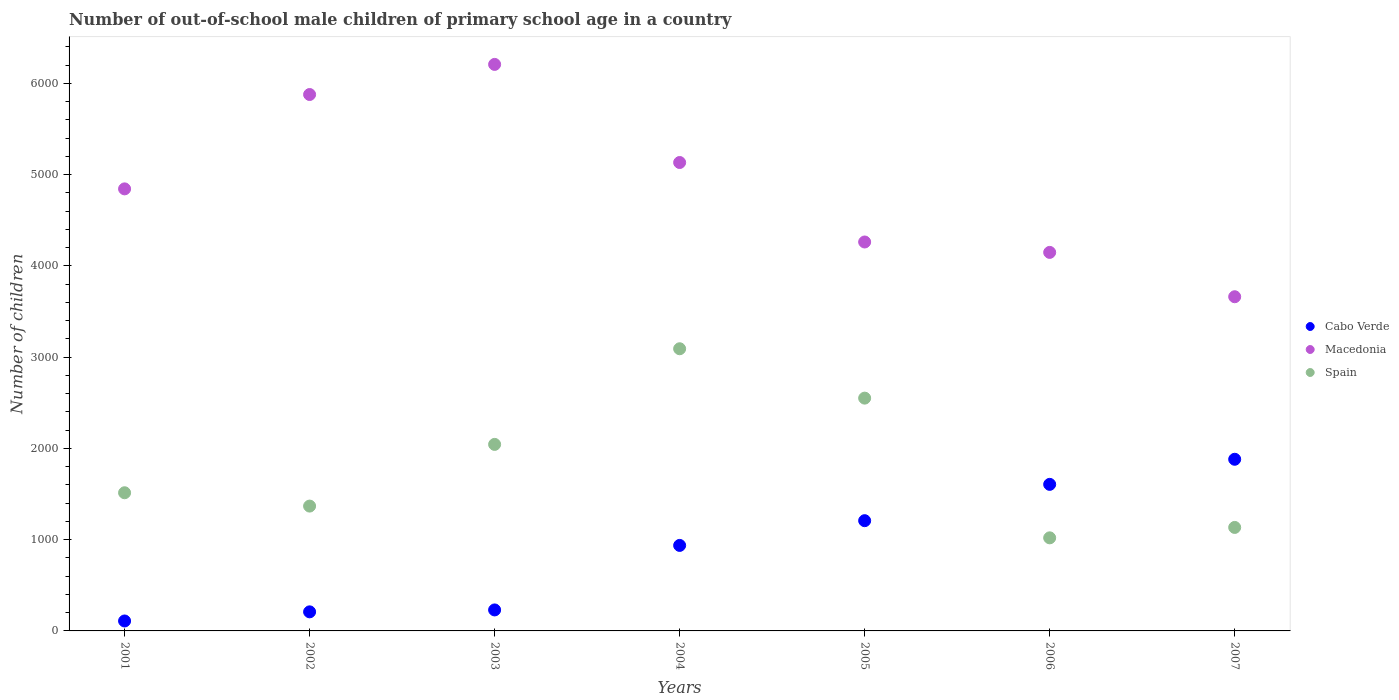How many different coloured dotlines are there?
Ensure brevity in your answer.  3. What is the number of out-of-school male children in Cabo Verde in 2003?
Ensure brevity in your answer.  230. Across all years, what is the maximum number of out-of-school male children in Spain?
Your response must be concise. 3092. Across all years, what is the minimum number of out-of-school male children in Cabo Verde?
Make the answer very short. 109. In which year was the number of out-of-school male children in Spain minimum?
Provide a succinct answer. 2006. What is the total number of out-of-school male children in Macedonia in the graph?
Give a very brief answer. 3.41e+04. What is the difference between the number of out-of-school male children in Spain in 2003 and that in 2005?
Make the answer very short. -507. What is the difference between the number of out-of-school male children in Spain in 2003 and the number of out-of-school male children in Cabo Verde in 2001?
Offer a very short reply. 1935. What is the average number of out-of-school male children in Spain per year?
Make the answer very short. 1817.57. In the year 2002, what is the difference between the number of out-of-school male children in Macedonia and number of out-of-school male children in Cabo Verde?
Your answer should be compact. 5669. In how many years, is the number of out-of-school male children in Cabo Verde greater than 1000?
Ensure brevity in your answer.  3. What is the ratio of the number of out-of-school male children in Macedonia in 2002 to that in 2006?
Your answer should be very brief. 1.42. Is the number of out-of-school male children in Macedonia in 2001 less than that in 2002?
Your answer should be compact. Yes. Is the difference between the number of out-of-school male children in Macedonia in 2003 and 2004 greater than the difference between the number of out-of-school male children in Cabo Verde in 2003 and 2004?
Ensure brevity in your answer.  Yes. What is the difference between the highest and the second highest number of out-of-school male children in Cabo Verde?
Your response must be concise. 275. What is the difference between the highest and the lowest number of out-of-school male children in Cabo Verde?
Offer a very short reply. 1772. In how many years, is the number of out-of-school male children in Spain greater than the average number of out-of-school male children in Spain taken over all years?
Your response must be concise. 3. Is the number of out-of-school male children in Macedonia strictly greater than the number of out-of-school male children in Cabo Verde over the years?
Provide a succinct answer. Yes. Is the number of out-of-school male children in Macedonia strictly less than the number of out-of-school male children in Spain over the years?
Give a very brief answer. No. How many years are there in the graph?
Give a very brief answer. 7. What is the difference between two consecutive major ticks on the Y-axis?
Keep it short and to the point. 1000. Are the values on the major ticks of Y-axis written in scientific E-notation?
Ensure brevity in your answer.  No. Does the graph contain grids?
Offer a terse response. No. How many legend labels are there?
Keep it short and to the point. 3. What is the title of the graph?
Your answer should be very brief. Number of out-of-school male children of primary school age in a country. Does "Bulgaria" appear as one of the legend labels in the graph?
Provide a short and direct response. No. What is the label or title of the Y-axis?
Ensure brevity in your answer.  Number of children. What is the Number of children in Cabo Verde in 2001?
Provide a short and direct response. 109. What is the Number of children of Macedonia in 2001?
Make the answer very short. 4844. What is the Number of children in Spain in 2001?
Your response must be concise. 1514. What is the Number of children in Cabo Verde in 2002?
Your response must be concise. 209. What is the Number of children of Macedonia in 2002?
Offer a very short reply. 5878. What is the Number of children in Spain in 2002?
Offer a terse response. 1368. What is the Number of children in Cabo Verde in 2003?
Ensure brevity in your answer.  230. What is the Number of children in Macedonia in 2003?
Provide a succinct answer. 6208. What is the Number of children of Spain in 2003?
Make the answer very short. 2044. What is the Number of children in Cabo Verde in 2004?
Give a very brief answer. 937. What is the Number of children of Macedonia in 2004?
Your response must be concise. 5133. What is the Number of children of Spain in 2004?
Give a very brief answer. 3092. What is the Number of children in Cabo Verde in 2005?
Your answer should be compact. 1208. What is the Number of children in Macedonia in 2005?
Ensure brevity in your answer.  4262. What is the Number of children in Spain in 2005?
Your response must be concise. 2551. What is the Number of children in Cabo Verde in 2006?
Keep it short and to the point. 1606. What is the Number of children in Macedonia in 2006?
Give a very brief answer. 4148. What is the Number of children of Spain in 2006?
Give a very brief answer. 1020. What is the Number of children of Cabo Verde in 2007?
Provide a short and direct response. 1881. What is the Number of children of Macedonia in 2007?
Your answer should be compact. 3662. What is the Number of children in Spain in 2007?
Provide a short and direct response. 1134. Across all years, what is the maximum Number of children of Cabo Verde?
Give a very brief answer. 1881. Across all years, what is the maximum Number of children of Macedonia?
Provide a short and direct response. 6208. Across all years, what is the maximum Number of children in Spain?
Ensure brevity in your answer.  3092. Across all years, what is the minimum Number of children of Cabo Verde?
Your answer should be compact. 109. Across all years, what is the minimum Number of children in Macedonia?
Give a very brief answer. 3662. Across all years, what is the minimum Number of children of Spain?
Offer a very short reply. 1020. What is the total Number of children in Cabo Verde in the graph?
Make the answer very short. 6180. What is the total Number of children of Macedonia in the graph?
Your answer should be very brief. 3.41e+04. What is the total Number of children in Spain in the graph?
Your answer should be very brief. 1.27e+04. What is the difference between the Number of children of Cabo Verde in 2001 and that in 2002?
Make the answer very short. -100. What is the difference between the Number of children of Macedonia in 2001 and that in 2002?
Keep it short and to the point. -1034. What is the difference between the Number of children in Spain in 2001 and that in 2002?
Offer a terse response. 146. What is the difference between the Number of children of Cabo Verde in 2001 and that in 2003?
Your answer should be compact. -121. What is the difference between the Number of children of Macedonia in 2001 and that in 2003?
Offer a terse response. -1364. What is the difference between the Number of children of Spain in 2001 and that in 2003?
Your answer should be very brief. -530. What is the difference between the Number of children of Cabo Verde in 2001 and that in 2004?
Your answer should be compact. -828. What is the difference between the Number of children of Macedonia in 2001 and that in 2004?
Your answer should be compact. -289. What is the difference between the Number of children of Spain in 2001 and that in 2004?
Your response must be concise. -1578. What is the difference between the Number of children of Cabo Verde in 2001 and that in 2005?
Keep it short and to the point. -1099. What is the difference between the Number of children in Macedonia in 2001 and that in 2005?
Your response must be concise. 582. What is the difference between the Number of children in Spain in 2001 and that in 2005?
Keep it short and to the point. -1037. What is the difference between the Number of children of Cabo Verde in 2001 and that in 2006?
Your answer should be very brief. -1497. What is the difference between the Number of children in Macedonia in 2001 and that in 2006?
Your response must be concise. 696. What is the difference between the Number of children of Spain in 2001 and that in 2006?
Provide a succinct answer. 494. What is the difference between the Number of children in Cabo Verde in 2001 and that in 2007?
Offer a very short reply. -1772. What is the difference between the Number of children of Macedonia in 2001 and that in 2007?
Make the answer very short. 1182. What is the difference between the Number of children of Spain in 2001 and that in 2007?
Ensure brevity in your answer.  380. What is the difference between the Number of children of Cabo Verde in 2002 and that in 2003?
Your answer should be very brief. -21. What is the difference between the Number of children in Macedonia in 2002 and that in 2003?
Make the answer very short. -330. What is the difference between the Number of children in Spain in 2002 and that in 2003?
Your answer should be very brief. -676. What is the difference between the Number of children of Cabo Verde in 2002 and that in 2004?
Give a very brief answer. -728. What is the difference between the Number of children in Macedonia in 2002 and that in 2004?
Your answer should be very brief. 745. What is the difference between the Number of children in Spain in 2002 and that in 2004?
Offer a very short reply. -1724. What is the difference between the Number of children of Cabo Verde in 2002 and that in 2005?
Provide a succinct answer. -999. What is the difference between the Number of children in Macedonia in 2002 and that in 2005?
Keep it short and to the point. 1616. What is the difference between the Number of children of Spain in 2002 and that in 2005?
Make the answer very short. -1183. What is the difference between the Number of children of Cabo Verde in 2002 and that in 2006?
Your answer should be compact. -1397. What is the difference between the Number of children of Macedonia in 2002 and that in 2006?
Your response must be concise. 1730. What is the difference between the Number of children in Spain in 2002 and that in 2006?
Offer a terse response. 348. What is the difference between the Number of children of Cabo Verde in 2002 and that in 2007?
Your answer should be very brief. -1672. What is the difference between the Number of children of Macedonia in 2002 and that in 2007?
Make the answer very short. 2216. What is the difference between the Number of children in Spain in 2002 and that in 2007?
Your response must be concise. 234. What is the difference between the Number of children of Cabo Verde in 2003 and that in 2004?
Provide a short and direct response. -707. What is the difference between the Number of children in Macedonia in 2003 and that in 2004?
Provide a succinct answer. 1075. What is the difference between the Number of children in Spain in 2003 and that in 2004?
Offer a terse response. -1048. What is the difference between the Number of children in Cabo Verde in 2003 and that in 2005?
Ensure brevity in your answer.  -978. What is the difference between the Number of children in Macedonia in 2003 and that in 2005?
Ensure brevity in your answer.  1946. What is the difference between the Number of children in Spain in 2003 and that in 2005?
Provide a short and direct response. -507. What is the difference between the Number of children of Cabo Verde in 2003 and that in 2006?
Keep it short and to the point. -1376. What is the difference between the Number of children in Macedonia in 2003 and that in 2006?
Give a very brief answer. 2060. What is the difference between the Number of children in Spain in 2003 and that in 2006?
Offer a very short reply. 1024. What is the difference between the Number of children in Cabo Verde in 2003 and that in 2007?
Your answer should be compact. -1651. What is the difference between the Number of children of Macedonia in 2003 and that in 2007?
Your answer should be compact. 2546. What is the difference between the Number of children in Spain in 2003 and that in 2007?
Ensure brevity in your answer.  910. What is the difference between the Number of children in Cabo Verde in 2004 and that in 2005?
Give a very brief answer. -271. What is the difference between the Number of children of Macedonia in 2004 and that in 2005?
Your response must be concise. 871. What is the difference between the Number of children in Spain in 2004 and that in 2005?
Your answer should be very brief. 541. What is the difference between the Number of children of Cabo Verde in 2004 and that in 2006?
Your answer should be very brief. -669. What is the difference between the Number of children of Macedonia in 2004 and that in 2006?
Your answer should be very brief. 985. What is the difference between the Number of children of Spain in 2004 and that in 2006?
Offer a very short reply. 2072. What is the difference between the Number of children of Cabo Verde in 2004 and that in 2007?
Give a very brief answer. -944. What is the difference between the Number of children in Macedonia in 2004 and that in 2007?
Offer a terse response. 1471. What is the difference between the Number of children in Spain in 2004 and that in 2007?
Offer a terse response. 1958. What is the difference between the Number of children in Cabo Verde in 2005 and that in 2006?
Make the answer very short. -398. What is the difference between the Number of children of Macedonia in 2005 and that in 2006?
Give a very brief answer. 114. What is the difference between the Number of children in Spain in 2005 and that in 2006?
Make the answer very short. 1531. What is the difference between the Number of children in Cabo Verde in 2005 and that in 2007?
Provide a short and direct response. -673. What is the difference between the Number of children of Macedonia in 2005 and that in 2007?
Provide a succinct answer. 600. What is the difference between the Number of children in Spain in 2005 and that in 2007?
Your answer should be compact. 1417. What is the difference between the Number of children in Cabo Verde in 2006 and that in 2007?
Your response must be concise. -275. What is the difference between the Number of children of Macedonia in 2006 and that in 2007?
Provide a short and direct response. 486. What is the difference between the Number of children in Spain in 2006 and that in 2007?
Ensure brevity in your answer.  -114. What is the difference between the Number of children in Cabo Verde in 2001 and the Number of children in Macedonia in 2002?
Make the answer very short. -5769. What is the difference between the Number of children of Cabo Verde in 2001 and the Number of children of Spain in 2002?
Give a very brief answer. -1259. What is the difference between the Number of children of Macedonia in 2001 and the Number of children of Spain in 2002?
Offer a very short reply. 3476. What is the difference between the Number of children of Cabo Verde in 2001 and the Number of children of Macedonia in 2003?
Ensure brevity in your answer.  -6099. What is the difference between the Number of children of Cabo Verde in 2001 and the Number of children of Spain in 2003?
Ensure brevity in your answer.  -1935. What is the difference between the Number of children in Macedonia in 2001 and the Number of children in Spain in 2003?
Your response must be concise. 2800. What is the difference between the Number of children in Cabo Verde in 2001 and the Number of children in Macedonia in 2004?
Your answer should be very brief. -5024. What is the difference between the Number of children of Cabo Verde in 2001 and the Number of children of Spain in 2004?
Keep it short and to the point. -2983. What is the difference between the Number of children in Macedonia in 2001 and the Number of children in Spain in 2004?
Offer a very short reply. 1752. What is the difference between the Number of children of Cabo Verde in 2001 and the Number of children of Macedonia in 2005?
Offer a terse response. -4153. What is the difference between the Number of children in Cabo Verde in 2001 and the Number of children in Spain in 2005?
Offer a terse response. -2442. What is the difference between the Number of children of Macedonia in 2001 and the Number of children of Spain in 2005?
Your response must be concise. 2293. What is the difference between the Number of children of Cabo Verde in 2001 and the Number of children of Macedonia in 2006?
Provide a succinct answer. -4039. What is the difference between the Number of children of Cabo Verde in 2001 and the Number of children of Spain in 2006?
Your answer should be compact. -911. What is the difference between the Number of children in Macedonia in 2001 and the Number of children in Spain in 2006?
Offer a very short reply. 3824. What is the difference between the Number of children in Cabo Verde in 2001 and the Number of children in Macedonia in 2007?
Your response must be concise. -3553. What is the difference between the Number of children of Cabo Verde in 2001 and the Number of children of Spain in 2007?
Offer a terse response. -1025. What is the difference between the Number of children of Macedonia in 2001 and the Number of children of Spain in 2007?
Make the answer very short. 3710. What is the difference between the Number of children of Cabo Verde in 2002 and the Number of children of Macedonia in 2003?
Keep it short and to the point. -5999. What is the difference between the Number of children in Cabo Verde in 2002 and the Number of children in Spain in 2003?
Ensure brevity in your answer.  -1835. What is the difference between the Number of children of Macedonia in 2002 and the Number of children of Spain in 2003?
Your answer should be compact. 3834. What is the difference between the Number of children of Cabo Verde in 2002 and the Number of children of Macedonia in 2004?
Your response must be concise. -4924. What is the difference between the Number of children of Cabo Verde in 2002 and the Number of children of Spain in 2004?
Provide a short and direct response. -2883. What is the difference between the Number of children of Macedonia in 2002 and the Number of children of Spain in 2004?
Provide a short and direct response. 2786. What is the difference between the Number of children of Cabo Verde in 2002 and the Number of children of Macedonia in 2005?
Your response must be concise. -4053. What is the difference between the Number of children in Cabo Verde in 2002 and the Number of children in Spain in 2005?
Your response must be concise. -2342. What is the difference between the Number of children of Macedonia in 2002 and the Number of children of Spain in 2005?
Give a very brief answer. 3327. What is the difference between the Number of children of Cabo Verde in 2002 and the Number of children of Macedonia in 2006?
Keep it short and to the point. -3939. What is the difference between the Number of children of Cabo Verde in 2002 and the Number of children of Spain in 2006?
Keep it short and to the point. -811. What is the difference between the Number of children in Macedonia in 2002 and the Number of children in Spain in 2006?
Offer a very short reply. 4858. What is the difference between the Number of children of Cabo Verde in 2002 and the Number of children of Macedonia in 2007?
Offer a terse response. -3453. What is the difference between the Number of children of Cabo Verde in 2002 and the Number of children of Spain in 2007?
Give a very brief answer. -925. What is the difference between the Number of children of Macedonia in 2002 and the Number of children of Spain in 2007?
Give a very brief answer. 4744. What is the difference between the Number of children in Cabo Verde in 2003 and the Number of children in Macedonia in 2004?
Give a very brief answer. -4903. What is the difference between the Number of children of Cabo Verde in 2003 and the Number of children of Spain in 2004?
Offer a terse response. -2862. What is the difference between the Number of children of Macedonia in 2003 and the Number of children of Spain in 2004?
Provide a short and direct response. 3116. What is the difference between the Number of children in Cabo Verde in 2003 and the Number of children in Macedonia in 2005?
Provide a short and direct response. -4032. What is the difference between the Number of children in Cabo Verde in 2003 and the Number of children in Spain in 2005?
Ensure brevity in your answer.  -2321. What is the difference between the Number of children in Macedonia in 2003 and the Number of children in Spain in 2005?
Keep it short and to the point. 3657. What is the difference between the Number of children in Cabo Verde in 2003 and the Number of children in Macedonia in 2006?
Keep it short and to the point. -3918. What is the difference between the Number of children in Cabo Verde in 2003 and the Number of children in Spain in 2006?
Your answer should be very brief. -790. What is the difference between the Number of children in Macedonia in 2003 and the Number of children in Spain in 2006?
Your answer should be very brief. 5188. What is the difference between the Number of children of Cabo Verde in 2003 and the Number of children of Macedonia in 2007?
Your answer should be compact. -3432. What is the difference between the Number of children of Cabo Verde in 2003 and the Number of children of Spain in 2007?
Your answer should be very brief. -904. What is the difference between the Number of children in Macedonia in 2003 and the Number of children in Spain in 2007?
Your answer should be compact. 5074. What is the difference between the Number of children of Cabo Verde in 2004 and the Number of children of Macedonia in 2005?
Your answer should be compact. -3325. What is the difference between the Number of children of Cabo Verde in 2004 and the Number of children of Spain in 2005?
Make the answer very short. -1614. What is the difference between the Number of children of Macedonia in 2004 and the Number of children of Spain in 2005?
Ensure brevity in your answer.  2582. What is the difference between the Number of children in Cabo Verde in 2004 and the Number of children in Macedonia in 2006?
Make the answer very short. -3211. What is the difference between the Number of children in Cabo Verde in 2004 and the Number of children in Spain in 2006?
Give a very brief answer. -83. What is the difference between the Number of children of Macedonia in 2004 and the Number of children of Spain in 2006?
Provide a succinct answer. 4113. What is the difference between the Number of children in Cabo Verde in 2004 and the Number of children in Macedonia in 2007?
Your response must be concise. -2725. What is the difference between the Number of children in Cabo Verde in 2004 and the Number of children in Spain in 2007?
Provide a succinct answer. -197. What is the difference between the Number of children of Macedonia in 2004 and the Number of children of Spain in 2007?
Provide a succinct answer. 3999. What is the difference between the Number of children in Cabo Verde in 2005 and the Number of children in Macedonia in 2006?
Your answer should be very brief. -2940. What is the difference between the Number of children in Cabo Verde in 2005 and the Number of children in Spain in 2006?
Your response must be concise. 188. What is the difference between the Number of children in Macedonia in 2005 and the Number of children in Spain in 2006?
Offer a terse response. 3242. What is the difference between the Number of children of Cabo Verde in 2005 and the Number of children of Macedonia in 2007?
Your answer should be compact. -2454. What is the difference between the Number of children in Macedonia in 2005 and the Number of children in Spain in 2007?
Your answer should be very brief. 3128. What is the difference between the Number of children of Cabo Verde in 2006 and the Number of children of Macedonia in 2007?
Give a very brief answer. -2056. What is the difference between the Number of children of Cabo Verde in 2006 and the Number of children of Spain in 2007?
Make the answer very short. 472. What is the difference between the Number of children in Macedonia in 2006 and the Number of children in Spain in 2007?
Offer a very short reply. 3014. What is the average Number of children of Cabo Verde per year?
Your answer should be very brief. 882.86. What is the average Number of children in Macedonia per year?
Give a very brief answer. 4876.43. What is the average Number of children in Spain per year?
Make the answer very short. 1817.57. In the year 2001, what is the difference between the Number of children of Cabo Verde and Number of children of Macedonia?
Ensure brevity in your answer.  -4735. In the year 2001, what is the difference between the Number of children in Cabo Verde and Number of children in Spain?
Provide a succinct answer. -1405. In the year 2001, what is the difference between the Number of children of Macedonia and Number of children of Spain?
Keep it short and to the point. 3330. In the year 2002, what is the difference between the Number of children of Cabo Verde and Number of children of Macedonia?
Your answer should be very brief. -5669. In the year 2002, what is the difference between the Number of children of Cabo Verde and Number of children of Spain?
Provide a succinct answer. -1159. In the year 2002, what is the difference between the Number of children of Macedonia and Number of children of Spain?
Offer a very short reply. 4510. In the year 2003, what is the difference between the Number of children in Cabo Verde and Number of children in Macedonia?
Offer a very short reply. -5978. In the year 2003, what is the difference between the Number of children of Cabo Verde and Number of children of Spain?
Offer a terse response. -1814. In the year 2003, what is the difference between the Number of children in Macedonia and Number of children in Spain?
Your answer should be compact. 4164. In the year 2004, what is the difference between the Number of children of Cabo Verde and Number of children of Macedonia?
Offer a terse response. -4196. In the year 2004, what is the difference between the Number of children of Cabo Verde and Number of children of Spain?
Your answer should be compact. -2155. In the year 2004, what is the difference between the Number of children in Macedonia and Number of children in Spain?
Give a very brief answer. 2041. In the year 2005, what is the difference between the Number of children of Cabo Verde and Number of children of Macedonia?
Keep it short and to the point. -3054. In the year 2005, what is the difference between the Number of children of Cabo Verde and Number of children of Spain?
Give a very brief answer. -1343. In the year 2005, what is the difference between the Number of children in Macedonia and Number of children in Spain?
Give a very brief answer. 1711. In the year 2006, what is the difference between the Number of children of Cabo Verde and Number of children of Macedonia?
Give a very brief answer. -2542. In the year 2006, what is the difference between the Number of children in Cabo Verde and Number of children in Spain?
Your answer should be compact. 586. In the year 2006, what is the difference between the Number of children of Macedonia and Number of children of Spain?
Your answer should be very brief. 3128. In the year 2007, what is the difference between the Number of children in Cabo Verde and Number of children in Macedonia?
Provide a short and direct response. -1781. In the year 2007, what is the difference between the Number of children of Cabo Verde and Number of children of Spain?
Your response must be concise. 747. In the year 2007, what is the difference between the Number of children in Macedonia and Number of children in Spain?
Your answer should be very brief. 2528. What is the ratio of the Number of children in Cabo Verde in 2001 to that in 2002?
Provide a succinct answer. 0.52. What is the ratio of the Number of children in Macedonia in 2001 to that in 2002?
Provide a short and direct response. 0.82. What is the ratio of the Number of children of Spain in 2001 to that in 2002?
Provide a short and direct response. 1.11. What is the ratio of the Number of children in Cabo Verde in 2001 to that in 2003?
Your response must be concise. 0.47. What is the ratio of the Number of children in Macedonia in 2001 to that in 2003?
Provide a short and direct response. 0.78. What is the ratio of the Number of children of Spain in 2001 to that in 2003?
Offer a very short reply. 0.74. What is the ratio of the Number of children of Cabo Verde in 2001 to that in 2004?
Your response must be concise. 0.12. What is the ratio of the Number of children in Macedonia in 2001 to that in 2004?
Provide a short and direct response. 0.94. What is the ratio of the Number of children of Spain in 2001 to that in 2004?
Keep it short and to the point. 0.49. What is the ratio of the Number of children of Cabo Verde in 2001 to that in 2005?
Your answer should be very brief. 0.09. What is the ratio of the Number of children in Macedonia in 2001 to that in 2005?
Ensure brevity in your answer.  1.14. What is the ratio of the Number of children in Spain in 2001 to that in 2005?
Your answer should be very brief. 0.59. What is the ratio of the Number of children in Cabo Verde in 2001 to that in 2006?
Offer a terse response. 0.07. What is the ratio of the Number of children of Macedonia in 2001 to that in 2006?
Provide a short and direct response. 1.17. What is the ratio of the Number of children in Spain in 2001 to that in 2006?
Offer a very short reply. 1.48. What is the ratio of the Number of children of Cabo Verde in 2001 to that in 2007?
Keep it short and to the point. 0.06. What is the ratio of the Number of children of Macedonia in 2001 to that in 2007?
Offer a very short reply. 1.32. What is the ratio of the Number of children in Spain in 2001 to that in 2007?
Provide a succinct answer. 1.34. What is the ratio of the Number of children of Cabo Verde in 2002 to that in 2003?
Give a very brief answer. 0.91. What is the ratio of the Number of children in Macedonia in 2002 to that in 2003?
Make the answer very short. 0.95. What is the ratio of the Number of children of Spain in 2002 to that in 2003?
Give a very brief answer. 0.67. What is the ratio of the Number of children in Cabo Verde in 2002 to that in 2004?
Make the answer very short. 0.22. What is the ratio of the Number of children of Macedonia in 2002 to that in 2004?
Keep it short and to the point. 1.15. What is the ratio of the Number of children of Spain in 2002 to that in 2004?
Keep it short and to the point. 0.44. What is the ratio of the Number of children of Cabo Verde in 2002 to that in 2005?
Your answer should be compact. 0.17. What is the ratio of the Number of children of Macedonia in 2002 to that in 2005?
Provide a succinct answer. 1.38. What is the ratio of the Number of children in Spain in 2002 to that in 2005?
Offer a terse response. 0.54. What is the ratio of the Number of children of Cabo Verde in 2002 to that in 2006?
Make the answer very short. 0.13. What is the ratio of the Number of children of Macedonia in 2002 to that in 2006?
Your answer should be very brief. 1.42. What is the ratio of the Number of children in Spain in 2002 to that in 2006?
Make the answer very short. 1.34. What is the ratio of the Number of children of Cabo Verde in 2002 to that in 2007?
Keep it short and to the point. 0.11. What is the ratio of the Number of children in Macedonia in 2002 to that in 2007?
Give a very brief answer. 1.61. What is the ratio of the Number of children in Spain in 2002 to that in 2007?
Make the answer very short. 1.21. What is the ratio of the Number of children of Cabo Verde in 2003 to that in 2004?
Provide a short and direct response. 0.25. What is the ratio of the Number of children of Macedonia in 2003 to that in 2004?
Keep it short and to the point. 1.21. What is the ratio of the Number of children in Spain in 2003 to that in 2004?
Your response must be concise. 0.66. What is the ratio of the Number of children of Cabo Verde in 2003 to that in 2005?
Ensure brevity in your answer.  0.19. What is the ratio of the Number of children in Macedonia in 2003 to that in 2005?
Your answer should be compact. 1.46. What is the ratio of the Number of children of Spain in 2003 to that in 2005?
Keep it short and to the point. 0.8. What is the ratio of the Number of children of Cabo Verde in 2003 to that in 2006?
Give a very brief answer. 0.14. What is the ratio of the Number of children of Macedonia in 2003 to that in 2006?
Ensure brevity in your answer.  1.5. What is the ratio of the Number of children in Spain in 2003 to that in 2006?
Keep it short and to the point. 2. What is the ratio of the Number of children in Cabo Verde in 2003 to that in 2007?
Provide a short and direct response. 0.12. What is the ratio of the Number of children of Macedonia in 2003 to that in 2007?
Give a very brief answer. 1.7. What is the ratio of the Number of children of Spain in 2003 to that in 2007?
Provide a short and direct response. 1.8. What is the ratio of the Number of children of Cabo Verde in 2004 to that in 2005?
Offer a very short reply. 0.78. What is the ratio of the Number of children in Macedonia in 2004 to that in 2005?
Your answer should be compact. 1.2. What is the ratio of the Number of children in Spain in 2004 to that in 2005?
Give a very brief answer. 1.21. What is the ratio of the Number of children in Cabo Verde in 2004 to that in 2006?
Provide a succinct answer. 0.58. What is the ratio of the Number of children in Macedonia in 2004 to that in 2006?
Your answer should be compact. 1.24. What is the ratio of the Number of children of Spain in 2004 to that in 2006?
Provide a short and direct response. 3.03. What is the ratio of the Number of children of Cabo Verde in 2004 to that in 2007?
Ensure brevity in your answer.  0.5. What is the ratio of the Number of children of Macedonia in 2004 to that in 2007?
Make the answer very short. 1.4. What is the ratio of the Number of children in Spain in 2004 to that in 2007?
Offer a terse response. 2.73. What is the ratio of the Number of children of Cabo Verde in 2005 to that in 2006?
Keep it short and to the point. 0.75. What is the ratio of the Number of children of Macedonia in 2005 to that in 2006?
Your response must be concise. 1.03. What is the ratio of the Number of children in Spain in 2005 to that in 2006?
Give a very brief answer. 2.5. What is the ratio of the Number of children in Cabo Verde in 2005 to that in 2007?
Your response must be concise. 0.64. What is the ratio of the Number of children of Macedonia in 2005 to that in 2007?
Give a very brief answer. 1.16. What is the ratio of the Number of children in Spain in 2005 to that in 2007?
Provide a succinct answer. 2.25. What is the ratio of the Number of children of Cabo Verde in 2006 to that in 2007?
Make the answer very short. 0.85. What is the ratio of the Number of children in Macedonia in 2006 to that in 2007?
Make the answer very short. 1.13. What is the ratio of the Number of children in Spain in 2006 to that in 2007?
Offer a terse response. 0.9. What is the difference between the highest and the second highest Number of children of Cabo Verde?
Provide a short and direct response. 275. What is the difference between the highest and the second highest Number of children in Macedonia?
Offer a very short reply. 330. What is the difference between the highest and the second highest Number of children of Spain?
Your response must be concise. 541. What is the difference between the highest and the lowest Number of children in Cabo Verde?
Your response must be concise. 1772. What is the difference between the highest and the lowest Number of children of Macedonia?
Offer a terse response. 2546. What is the difference between the highest and the lowest Number of children in Spain?
Offer a terse response. 2072. 